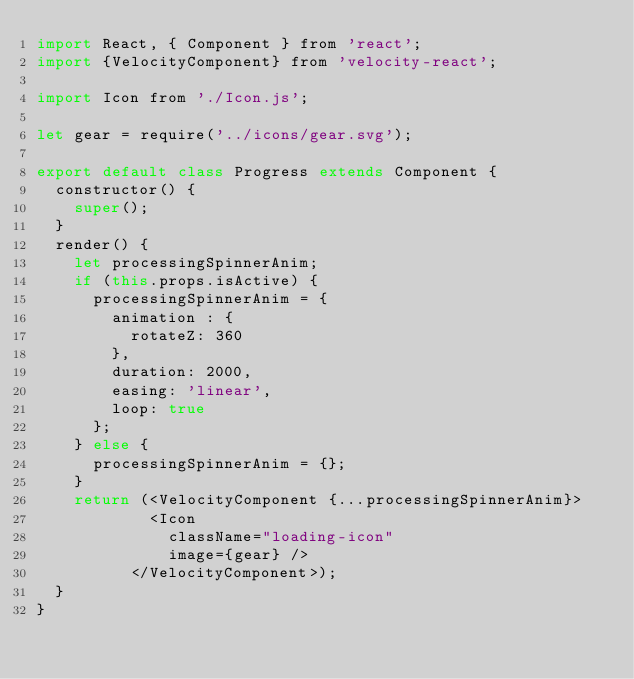<code> <loc_0><loc_0><loc_500><loc_500><_JavaScript_>import React, { Component } from 'react';
import {VelocityComponent} from 'velocity-react';

import Icon from './Icon.js';

let gear = require('../icons/gear.svg');

export default class Progress extends Component {
  constructor() {
    super();
  }
  render() {
    let processingSpinnerAnim;
    if (this.props.isActive) {
      processingSpinnerAnim = {
        animation : {
          rotateZ: 360
        },
        duration: 2000,
        easing: 'linear',
        loop: true
      };
    } else {
      processingSpinnerAnim = {};
    }
    return (<VelocityComponent {...processingSpinnerAnim}>
            <Icon
              className="loading-icon"
              image={gear} />
          </VelocityComponent>);
  }
}
</code> 